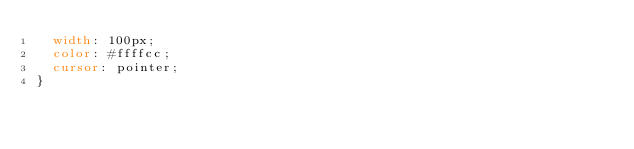<code> <loc_0><loc_0><loc_500><loc_500><_CSS_>	width: 100px;
	color: #ffffcc;
	cursor: pointer;
}
</code> 